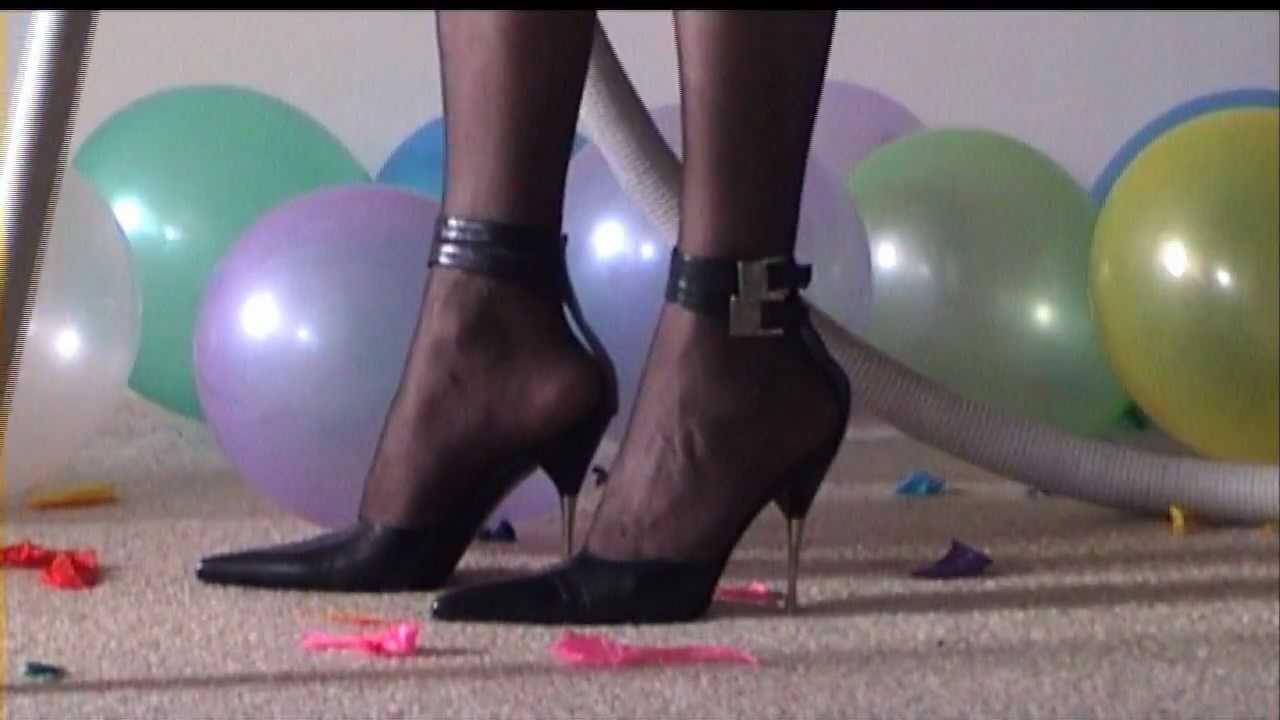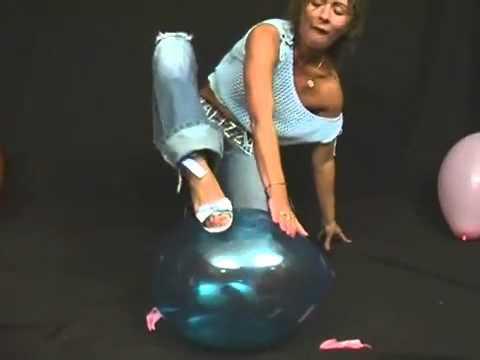The first image is the image on the left, the second image is the image on the right. For the images displayed, is the sentence "Someone is stepping on a blue balloon." factually correct? Answer yes or no. Yes. The first image is the image on the left, the second image is the image on the right. Given the left and right images, does the statement "There are two women stepping on balloons." hold true? Answer yes or no. No. 